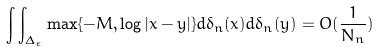<formula> <loc_0><loc_0><loc_500><loc_500>\int \int _ { \Delta _ { \epsilon } } \max \{ - M , \log | x - y | \} d \delta _ { n } ( x ) d \delta _ { n } ( y ) = O ( \frac { 1 } { N _ { n } } )</formula> 